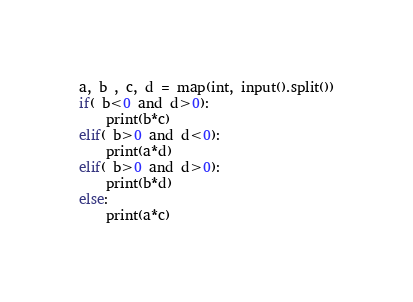<code> <loc_0><loc_0><loc_500><loc_500><_Python_>a, b , c, d = map(int, input().split())
if( b<0 and d>0):
    print(b*c)
elif( b>0 and d<0):
    print(a*d)
elif( b>0 and d>0):
    print(b*d)
else:
    print(a*c)</code> 